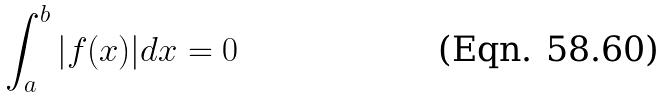Convert formula to latex. <formula><loc_0><loc_0><loc_500><loc_500>\int _ { a } ^ { b } | f ( x ) | d x = 0</formula> 